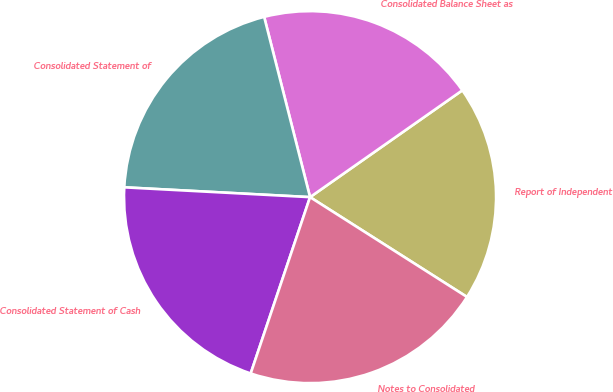Convert chart. <chart><loc_0><loc_0><loc_500><loc_500><pie_chart><fcel>Report of Independent<fcel>Consolidated Balance Sheet as<fcel>Consolidated Statement of<fcel>Consolidated Statement of Cash<fcel>Notes to Consolidated<nl><fcel>18.75%<fcel>19.23%<fcel>20.19%<fcel>20.67%<fcel>21.15%<nl></chart> 